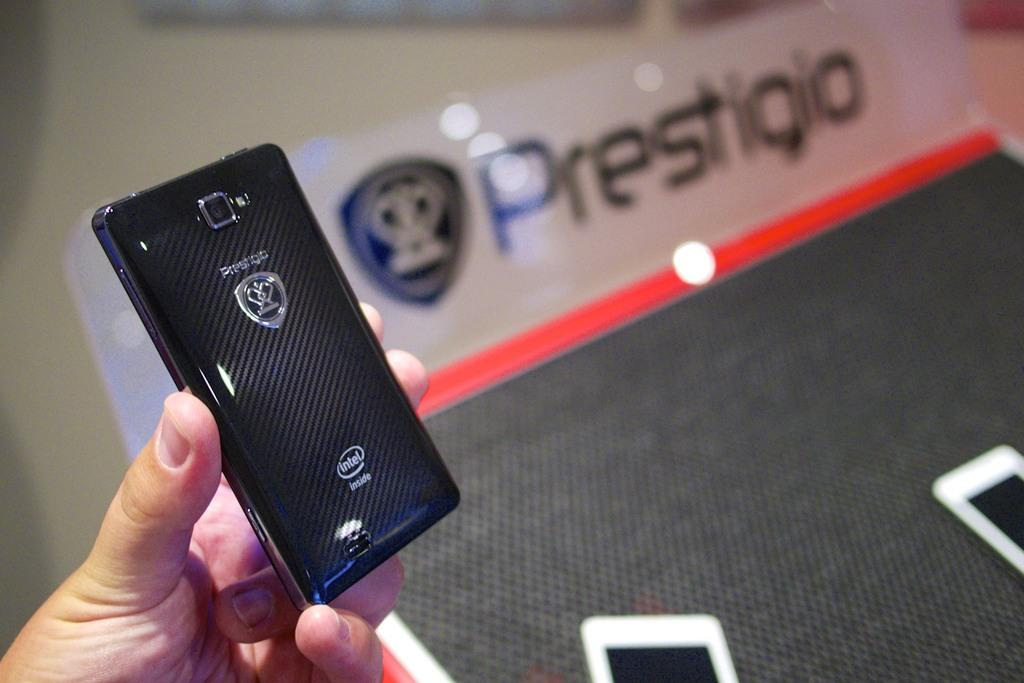<image>
Present a compact description of the photo's key features. hand holding black prestigio cellphone and 2 other phone on a tabletop 